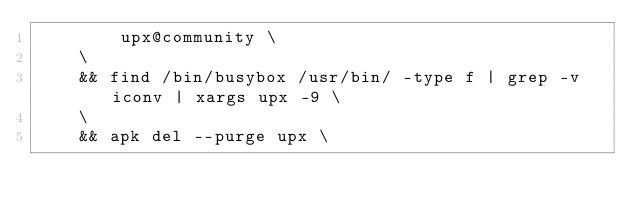Convert code to text. <code><loc_0><loc_0><loc_500><loc_500><_Dockerfile_>        upx@community \
    \
    && find /bin/busybox /usr/bin/ -type f | grep -v iconv | xargs upx -9 \
    \
    && apk del --purge upx \</code> 